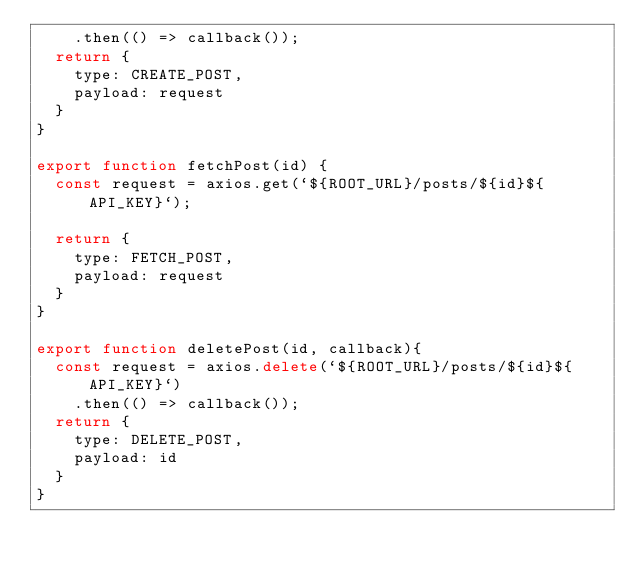Convert code to text. <code><loc_0><loc_0><loc_500><loc_500><_JavaScript_>    .then(() => callback());
  return {
    type: CREATE_POST,
    payload: request
  }
}

export function fetchPost(id) {
  const request = axios.get(`${ROOT_URL}/posts/${id}${API_KEY}`);

  return {
    type: FETCH_POST,
    payload: request
  }
}

export function deletePost(id, callback){
  const request = axios.delete(`${ROOT_URL}/posts/${id}${API_KEY}`)
    .then(() => callback());
  return {
    type: DELETE_POST,
    payload: id
  }
}
</code> 